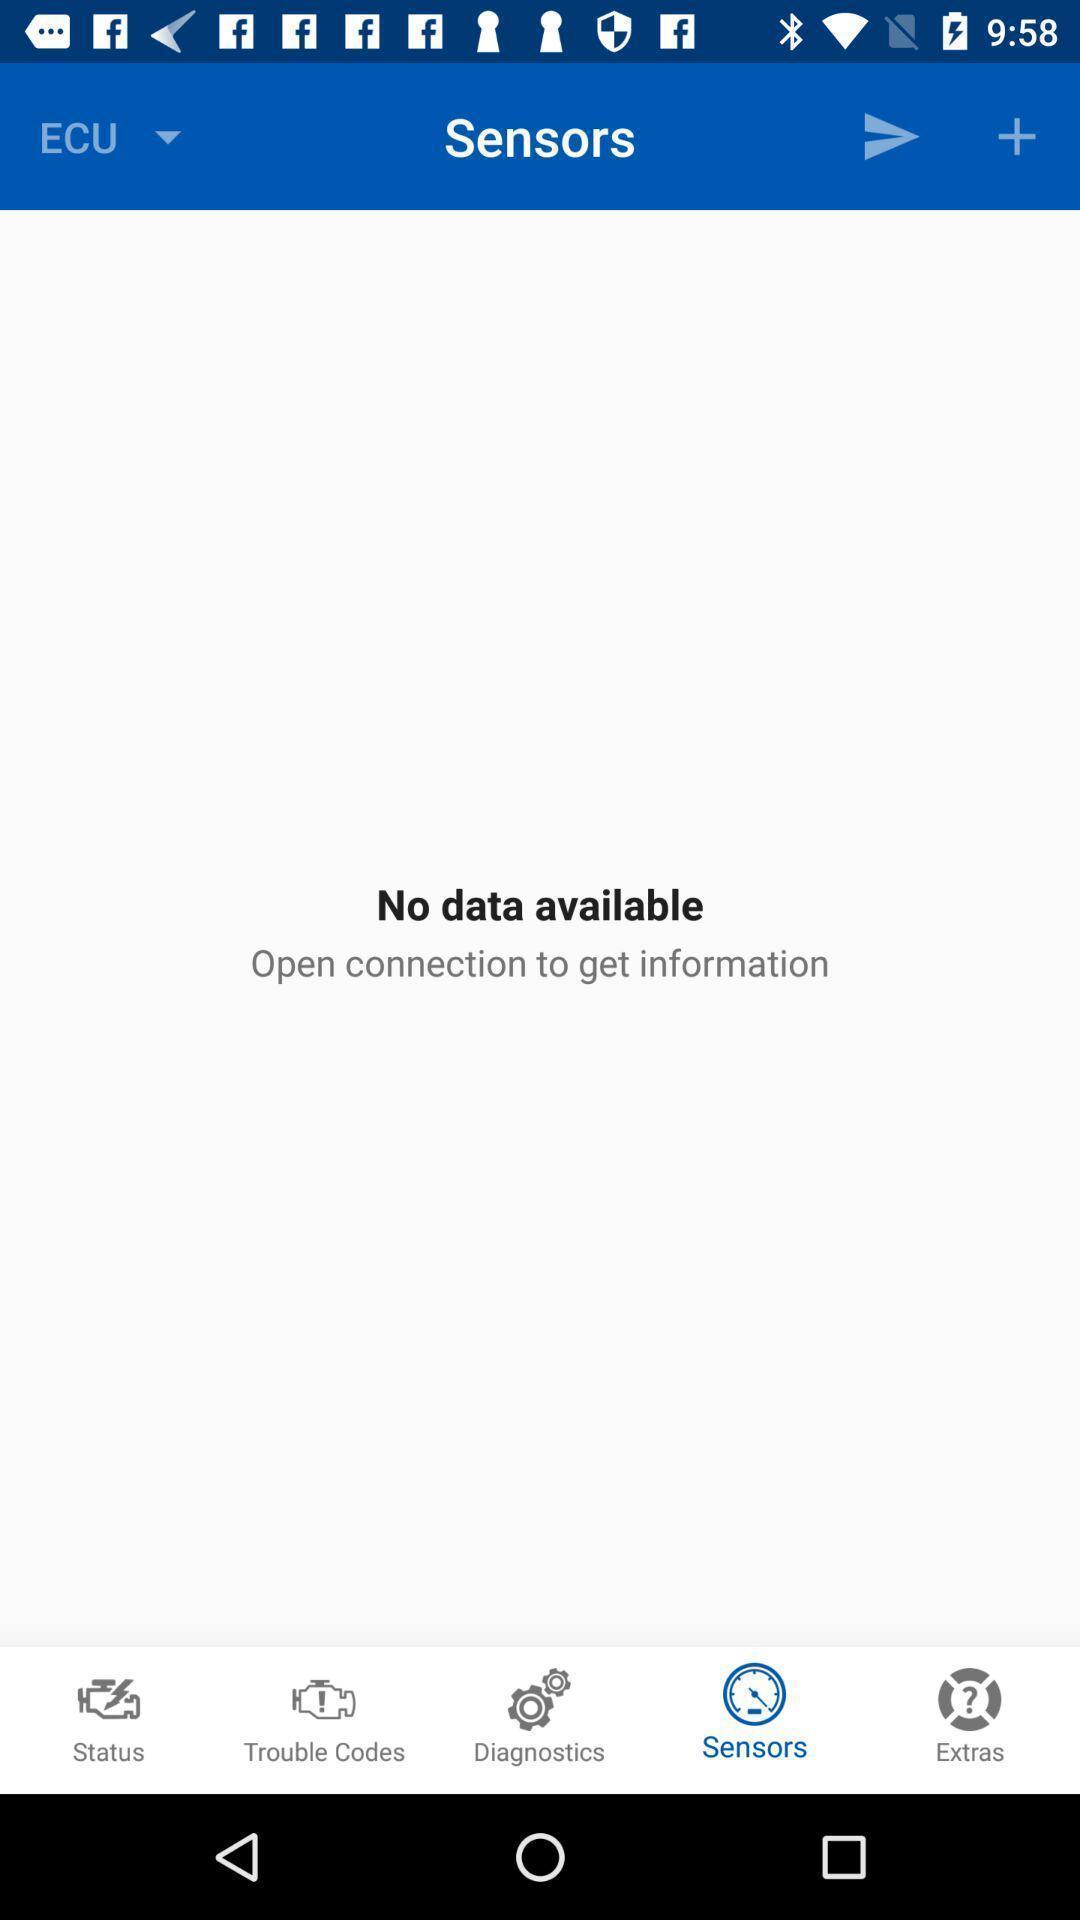Provide a description of this screenshot. Screen showing sensors page. 